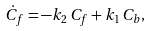Convert formula to latex. <formula><loc_0><loc_0><loc_500><loc_500>\dot { C } _ { f } = - k _ { 2 } \, C _ { f } + k _ { 1 } \, C _ { b } ,</formula> 